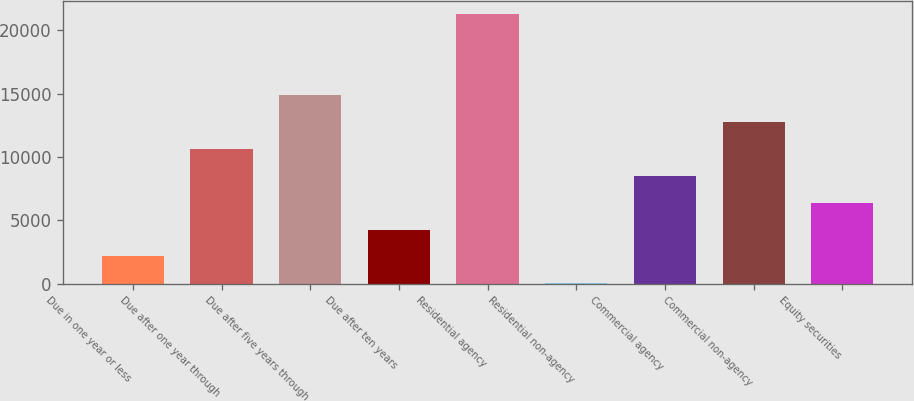Convert chart. <chart><loc_0><loc_0><loc_500><loc_500><bar_chart><fcel>Due in one year or less<fcel>Due after one year through<fcel>Due after five years through<fcel>Due after ten years<fcel>Residential agency<fcel>Residential non-agency<fcel>Commercial agency<fcel>Commercial non-agency<fcel>Equity securities<nl><fcel>2139.4<fcel>10645<fcel>14897.8<fcel>4265.8<fcel>21277<fcel>13<fcel>8518.6<fcel>12771.4<fcel>6392.2<nl></chart> 